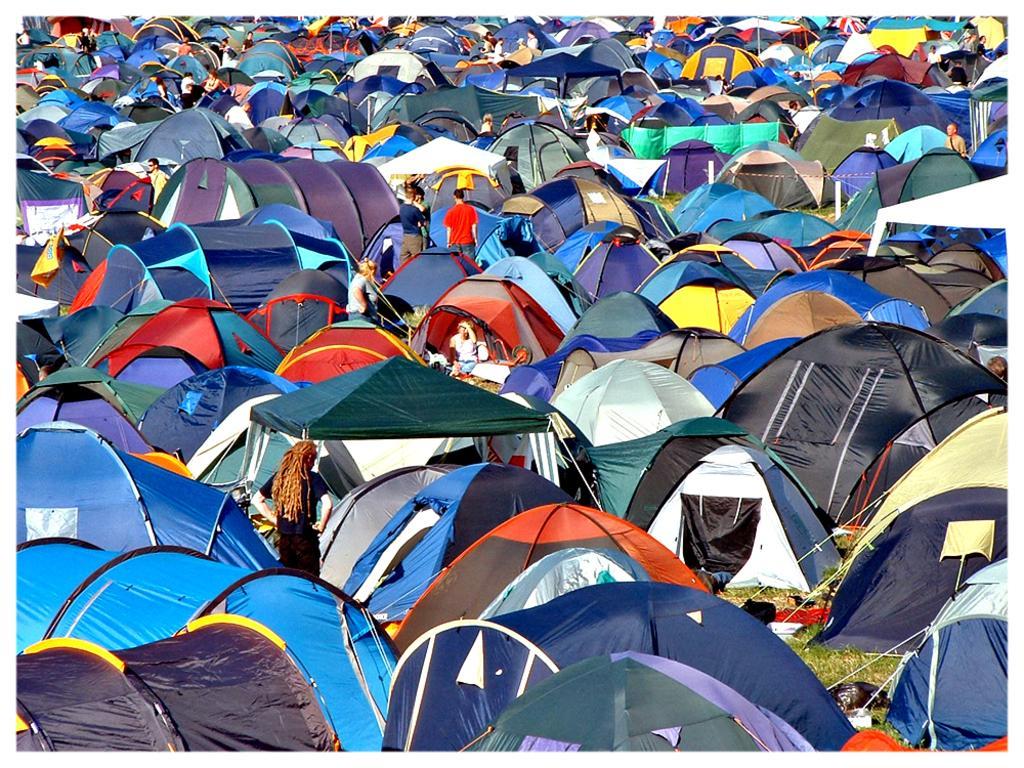Describe this image in one or two sentences. In this image we can see a group of tents on the grass. In the center of the image we can see some people standing. 